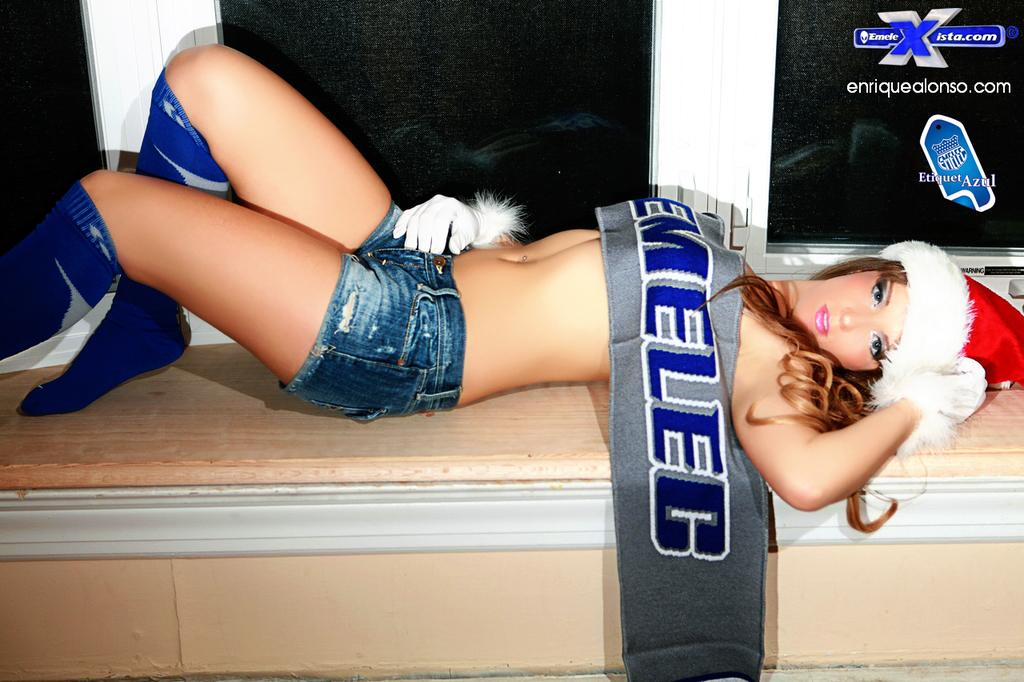<image>
Offer a succinct explanation of the picture presented. a fake girl laying down on a window sill where the window says 'enriquealonso.com' 